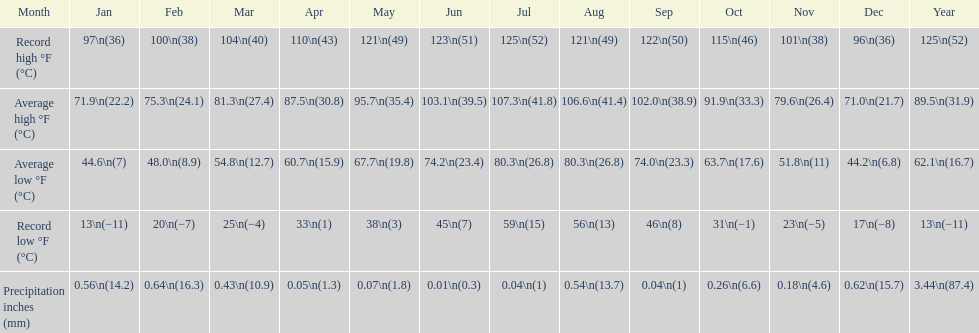What was the length of time when the monthly average temperature reached or exceeded 100 degrees? 4 months. 